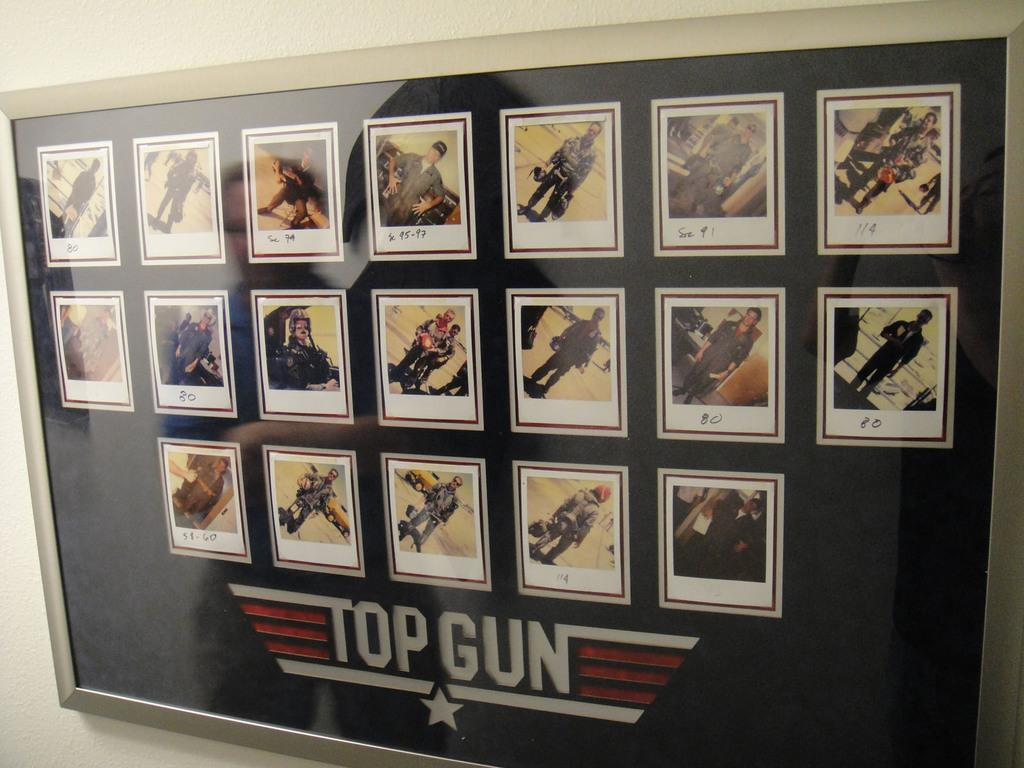<image>
Share a concise interpretation of the image provided. a picture that has Top Gun written at the bottom 